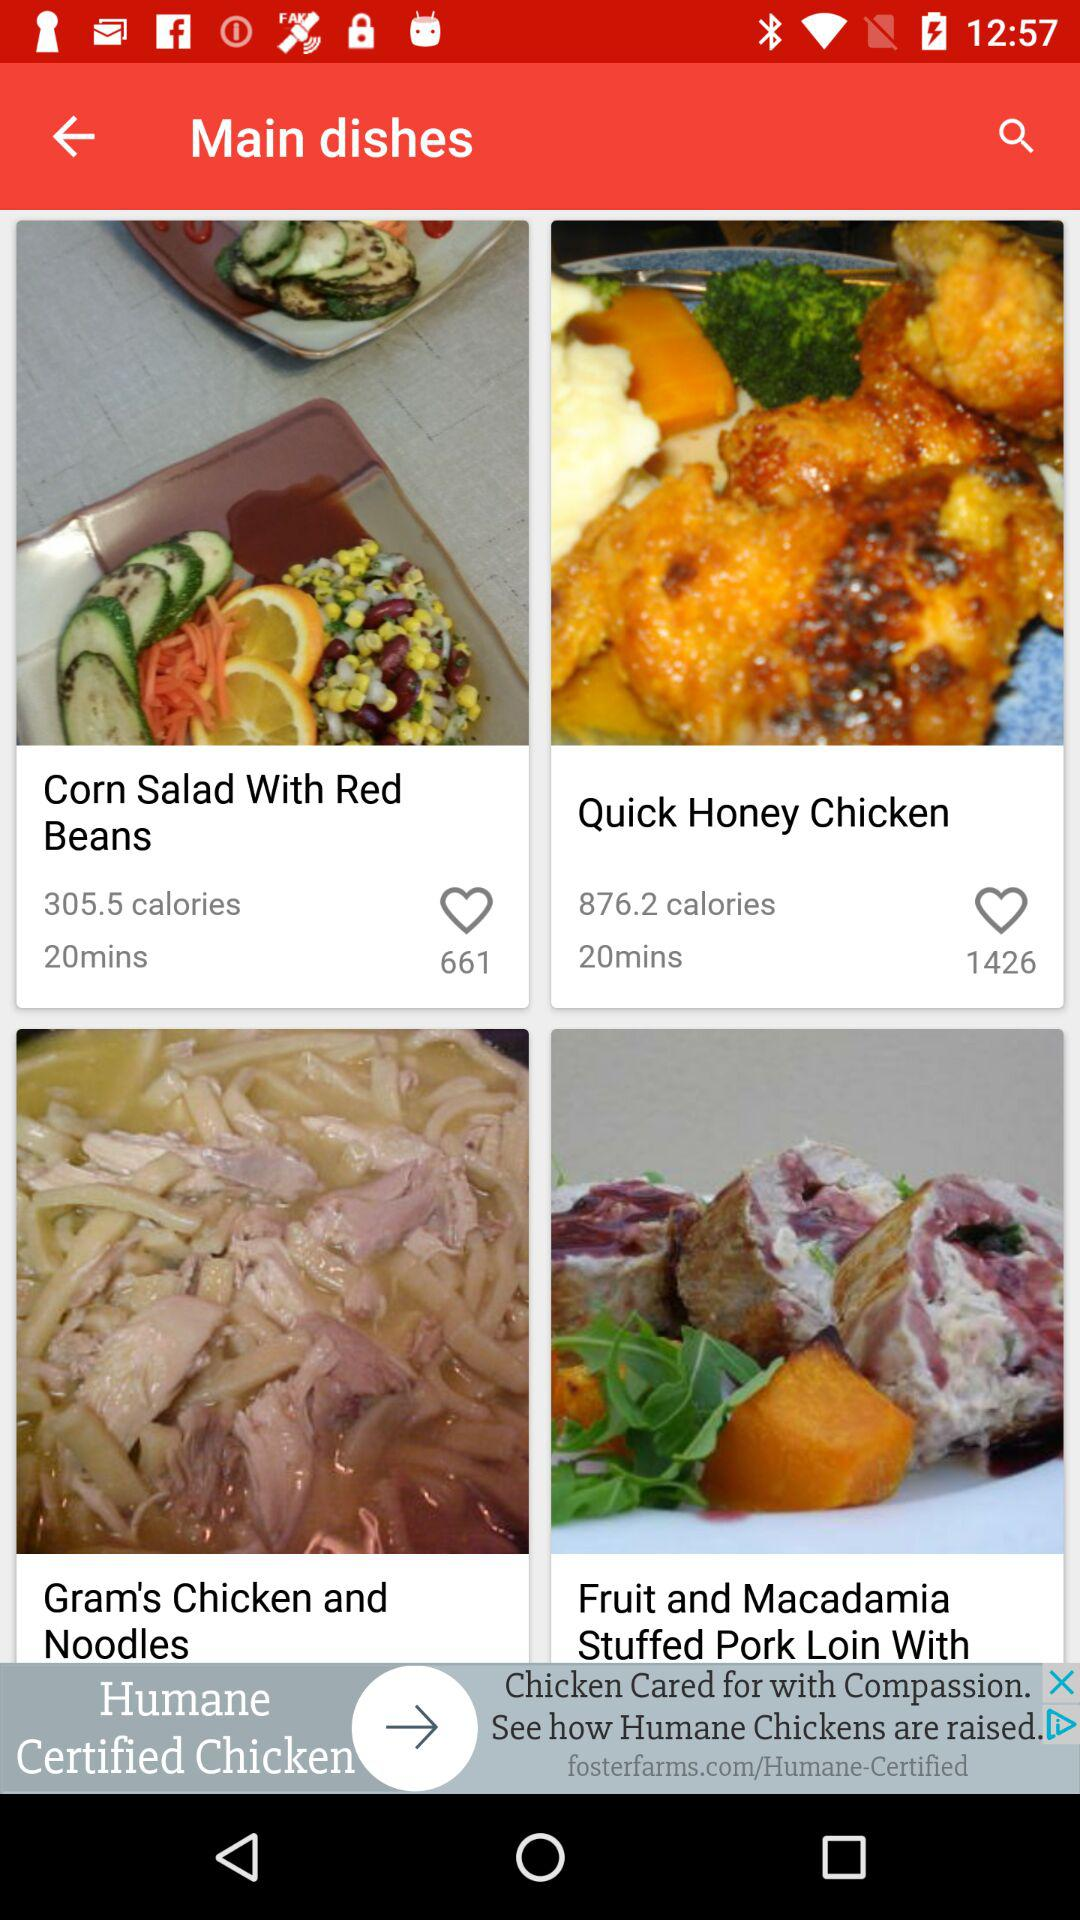How many likes are there for "Corn Salad With Red Beans"? There are 661 likes. 